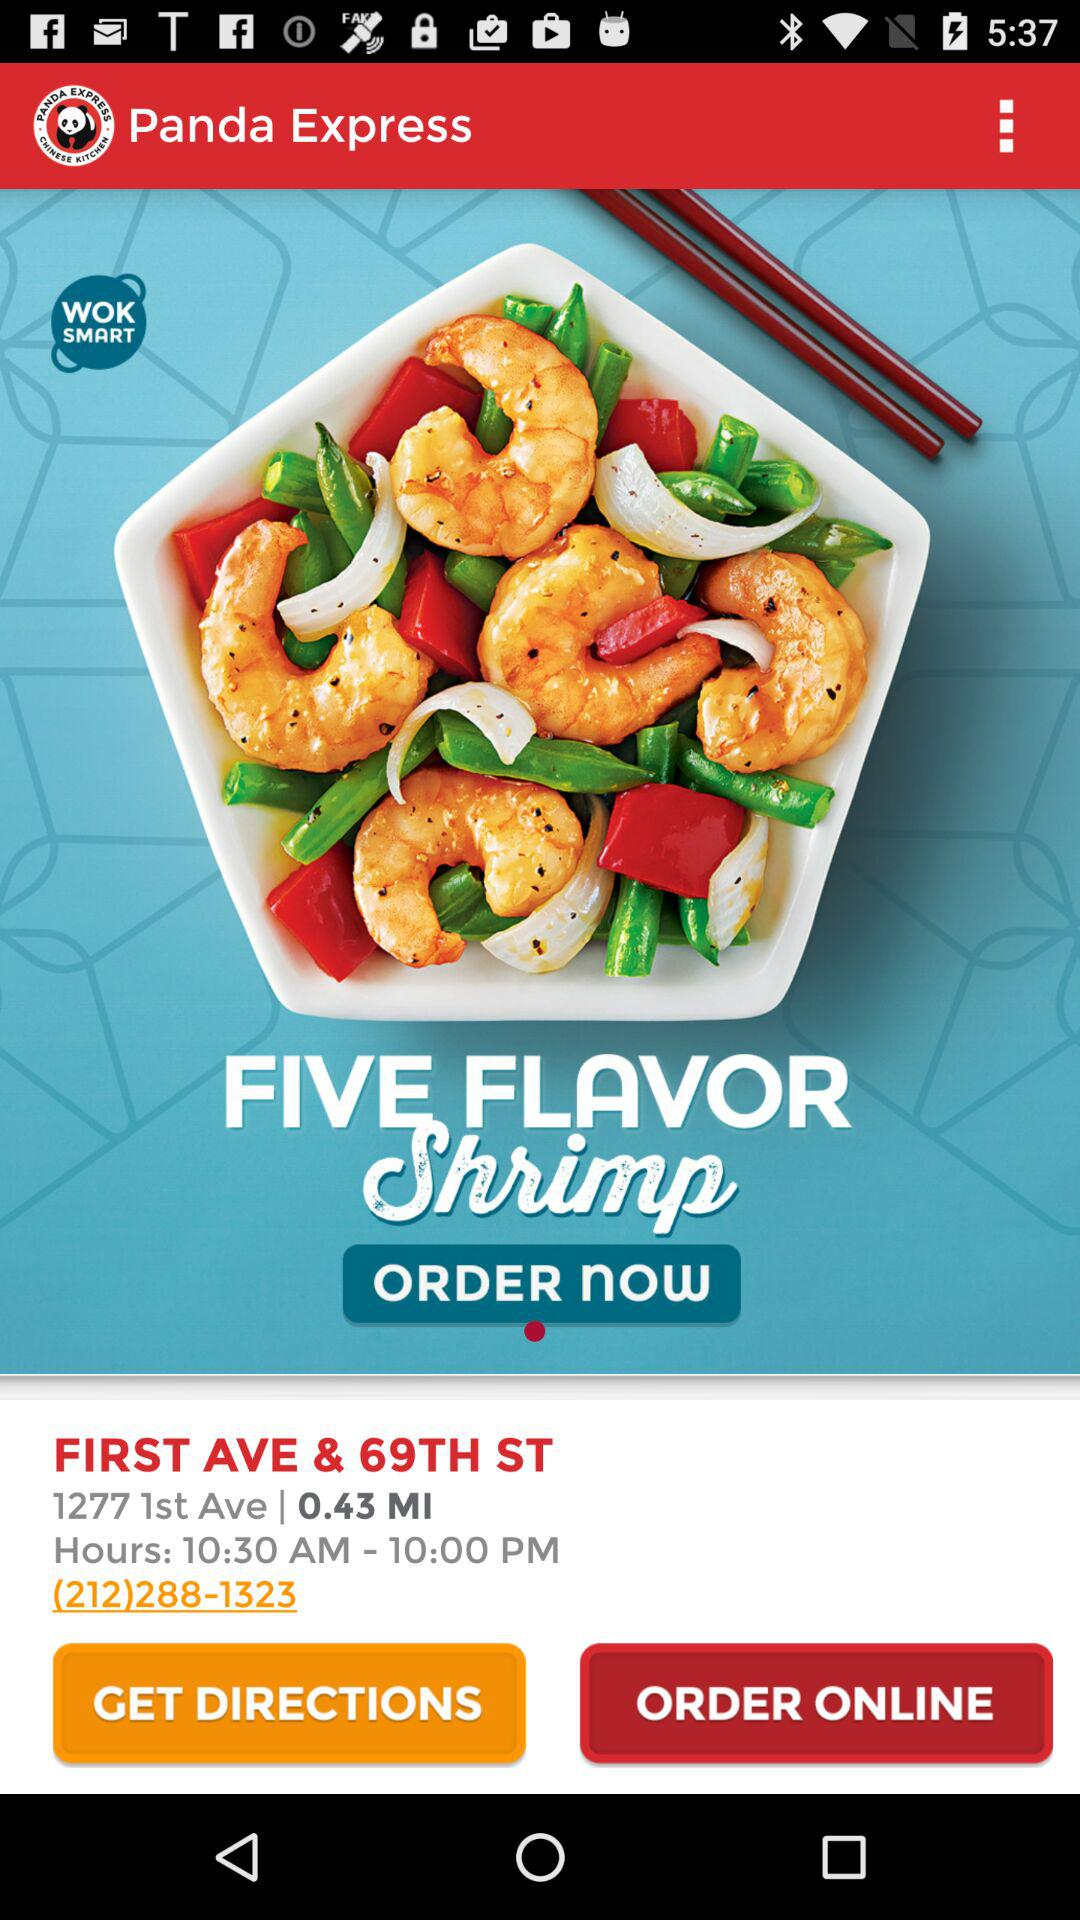What is the distance to the restaurant in miles?
Answer the question using a single word or phrase. 0.43 